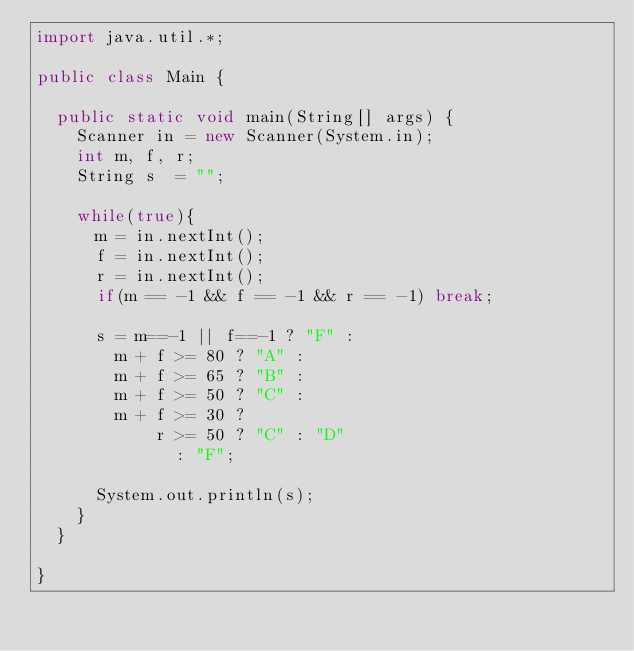<code> <loc_0><loc_0><loc_500><loc_500><_Java_>import java.util.*;

public class Main {

	public static void main(String[] args) {
		Scanner in = new Scanner(System.in);
		int m, f, r;
		String s  = "";
		
		while(true){
			m = in.nextInt();
			f = in.nextInt();
			r = in.nextInt();
			if(m == -1 && f == -1 && r == -1) break;
			
			s = m==-1 || f==-1 ? "F" :
				m + f >= 80 ? "A" :
				m + f >= 65 ? "B" :
				m + f >= 50 ? "C" :
				m + f >= 30 ?
						r >= 50 ? "C" : "D" 
							: "F";
			
			System.out.println(s);
		}
	}

}</code> 